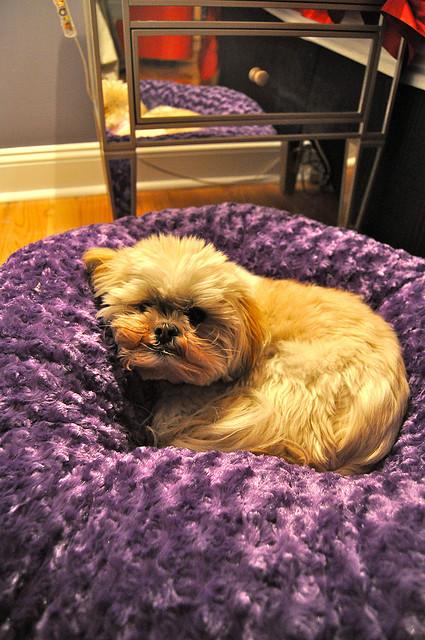What color is the bean bag chair?
Give a very brief answer. Purple. What kind of dog is that?
Answer briefly. Pekingese. Is the dog asleep?
Short answer required. No. 